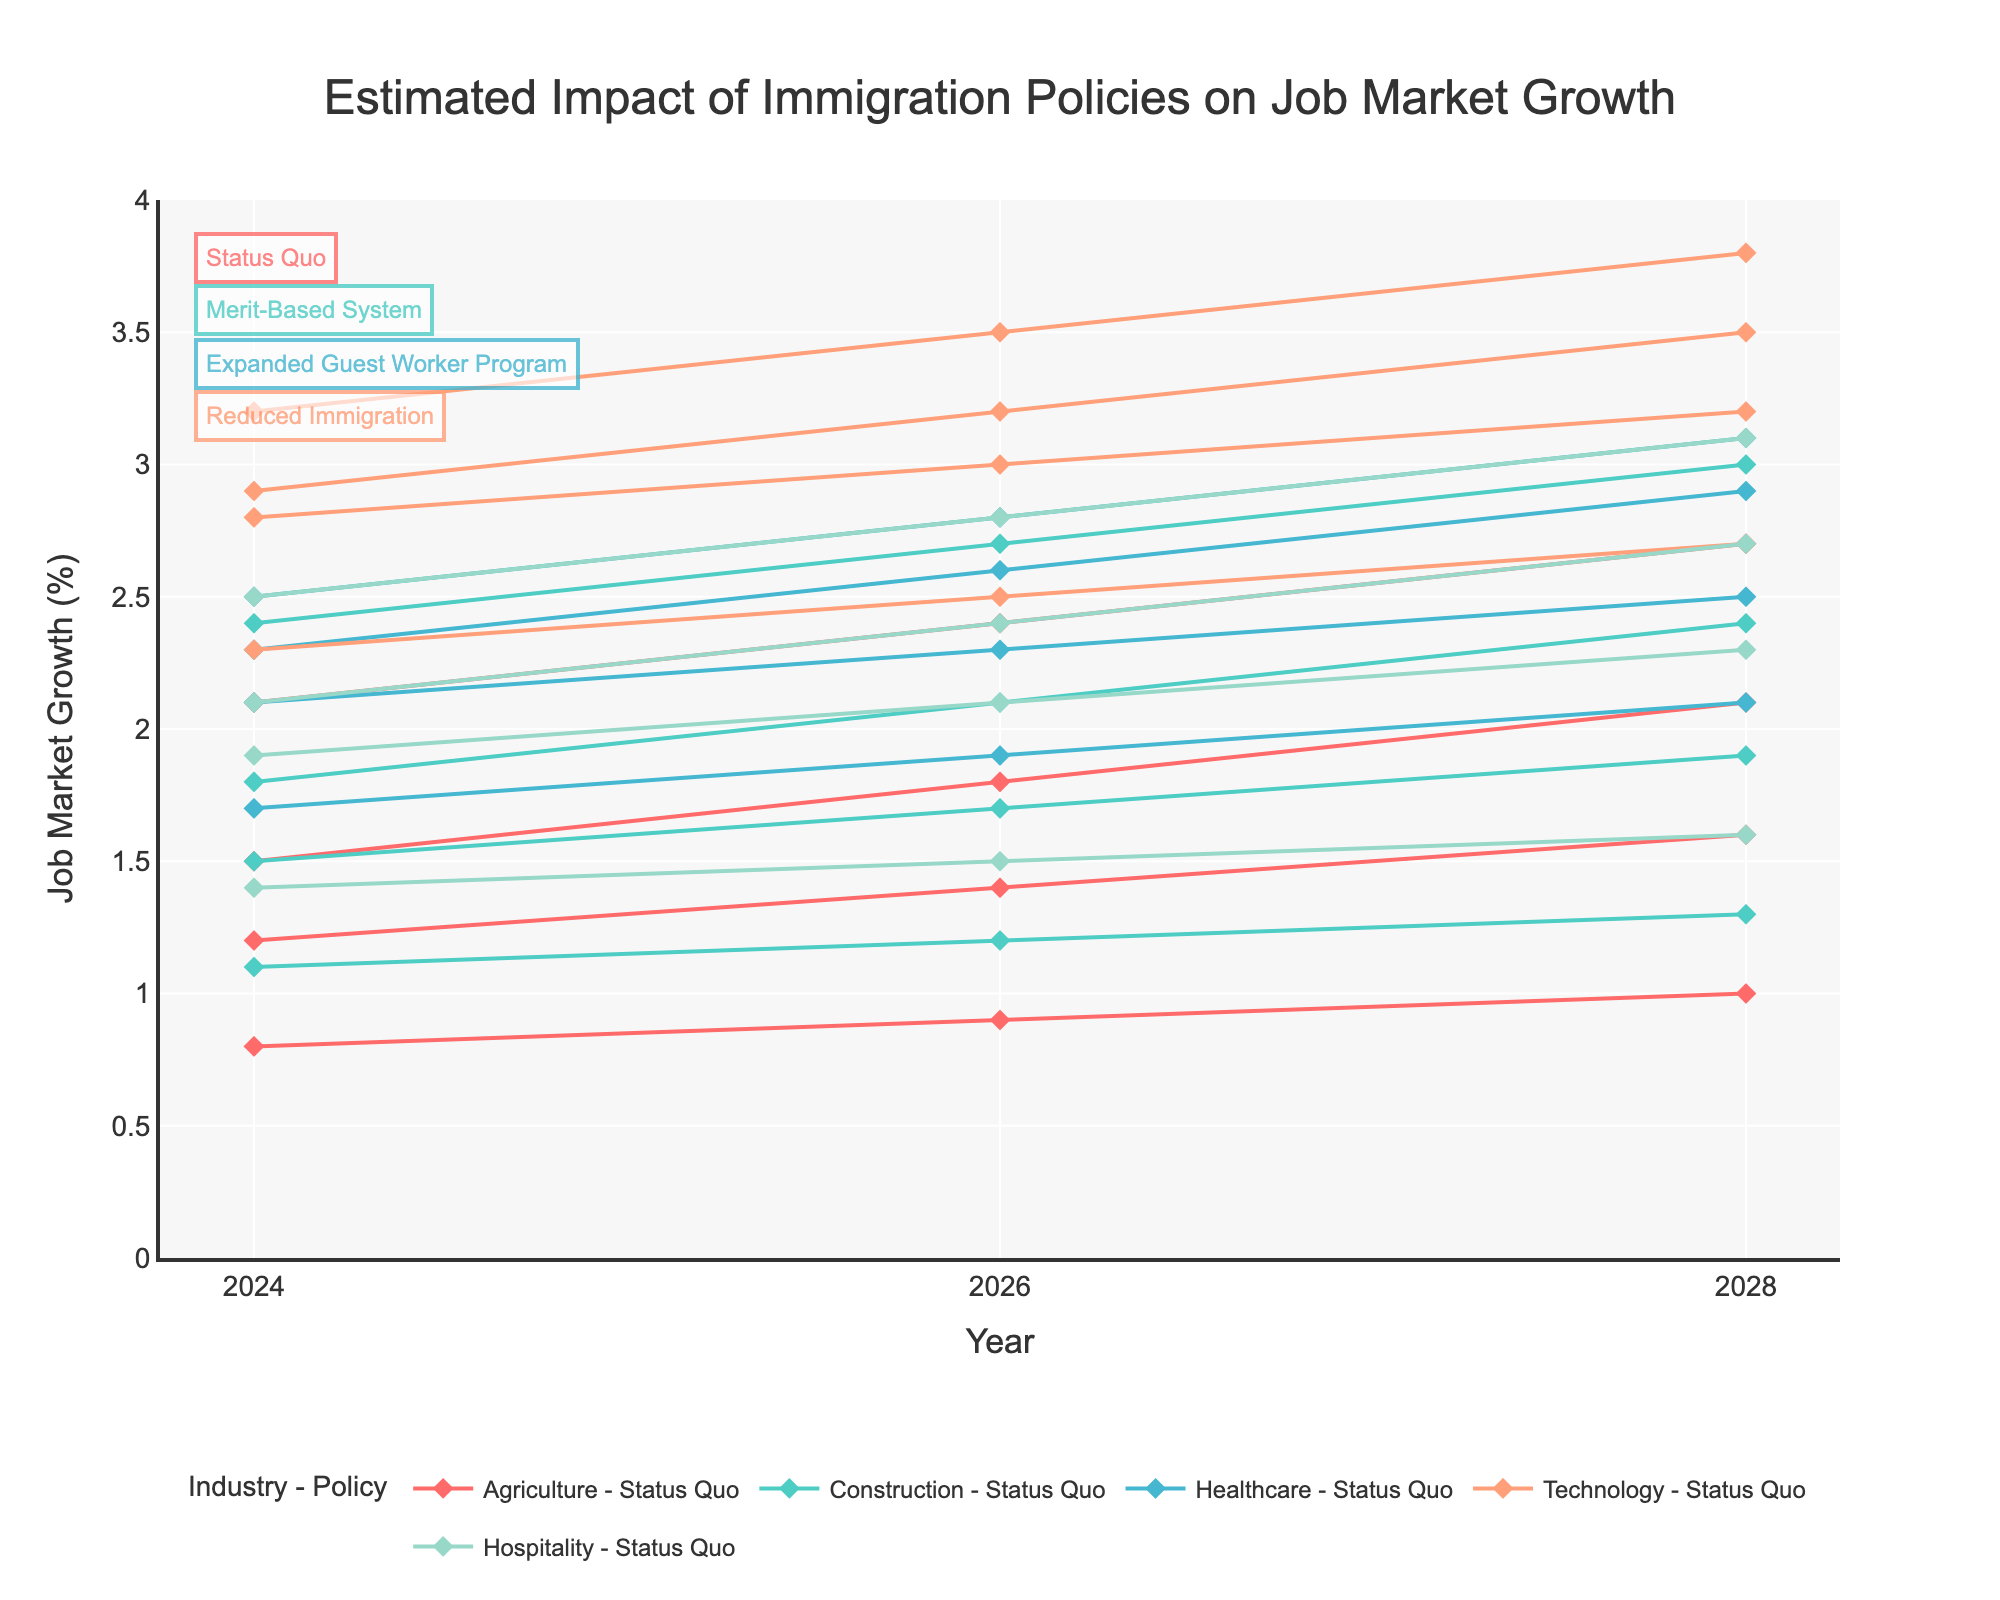What is the title of the chart? The title is usually displayed at the top of the chart. In this case, it reads "Estimated Impact of Immigration Policies on Job Market Growth".
Answer: Estimated Impact of Immigration Policies on Job Market Growth Which industry shows the highest job market growth under the Merit-Based System in 2024? Look at the lines representing the Merit-Based System for each industry in 2024. The highest point among these will show the highest growth.
Answer: Technology What is the difference in job market growth for the Agriculture industry between the Status Quo and Reduced Immigration policies in 2028? Find the Agriculture growth rates in 2028 for both the Status Quo and Reduced Immigration policies and calculate the difference: 1.6 (Status Quo) - 1.0 (Reduced Immigration) = 0.6.
Answer: 0.6 Which policy shows the greatest increase in construction job market growth from 2024 to 2028? Identify the growth values for Construction in each policy for the years 2024 and 2028. Calculate the difference for each policy and determine which has the greatest increase: {Status Quo: 1.9 - 1.5 = 0.4, Merit-Based: 2.4 - 1.8 = 0.6, Guest Worker: 3.0 - 2.4 = 0.6, Reduced Immigration: 1.3 - 1.1 = 0.2}. The highest increase is 0.6, shared by Merit-Based and Guest Worker policies.
Answer: Merit-Based System and Expanded Guest Worker Program For the Healthcare industry, which year and policy combination shows the maximum growth? Check the Healthcare growth rates across all years and policies and identify the maximum value and its corresponding year and policy: Healthcare (2028, Merit-Based System) = 3.1%.
Answer: 2028, Merit-Based System Does the Reduced Immigration policy show an increasing or decreasing trend in job market growth for the Technology sector from 2024 to 2028? Observe the Technology sector growth under the Reduced Immigration policy for the years 2024 (2.3), 2026 (2.5), and 2028 (2.7). Since it shows an increase over these years, it's an increasing trend.
Answer: Increasing How does the Hospitality industry trend compare between the Merit-Based System and Expanded Guest Worker Program in 2026? Compare the growth rates for the Hospitality industry under both policies in 2026: Merit-Based System (2.4), Expanded Guest Worker Program (2.8).
Answer: Expanded Guest Worker Program has higher growth What are the colors representing the Technology sector across different policies? Identify the line colors used for the Technology sector. According to the color scheme, Technology is represented by the fourth color in the custom palette, which is a shade of light coral (appears warm pink).
Answer: Light coral How does the construction job market growth in 2026 compare with the healthcare job market growth under the Status Quo policy? Find the growth rates for Construction and Healthcare in 2026 under the Status Quo policy: Construction (1.7), Healthcare (2.3). Construction is lower than Healthcare.
Answer: Lower For which policy does the Agriculture industry have the most consistent growth pattern across all years? Check the Agriculture growth rates for uniformity across years for each policy. The Expanded Guest Worker Program shows consistent and relatively high growth: (2024: 2.1, 2026: 2.4, 2028: 2.7).
Answer: Expanded Guest Worker Program 